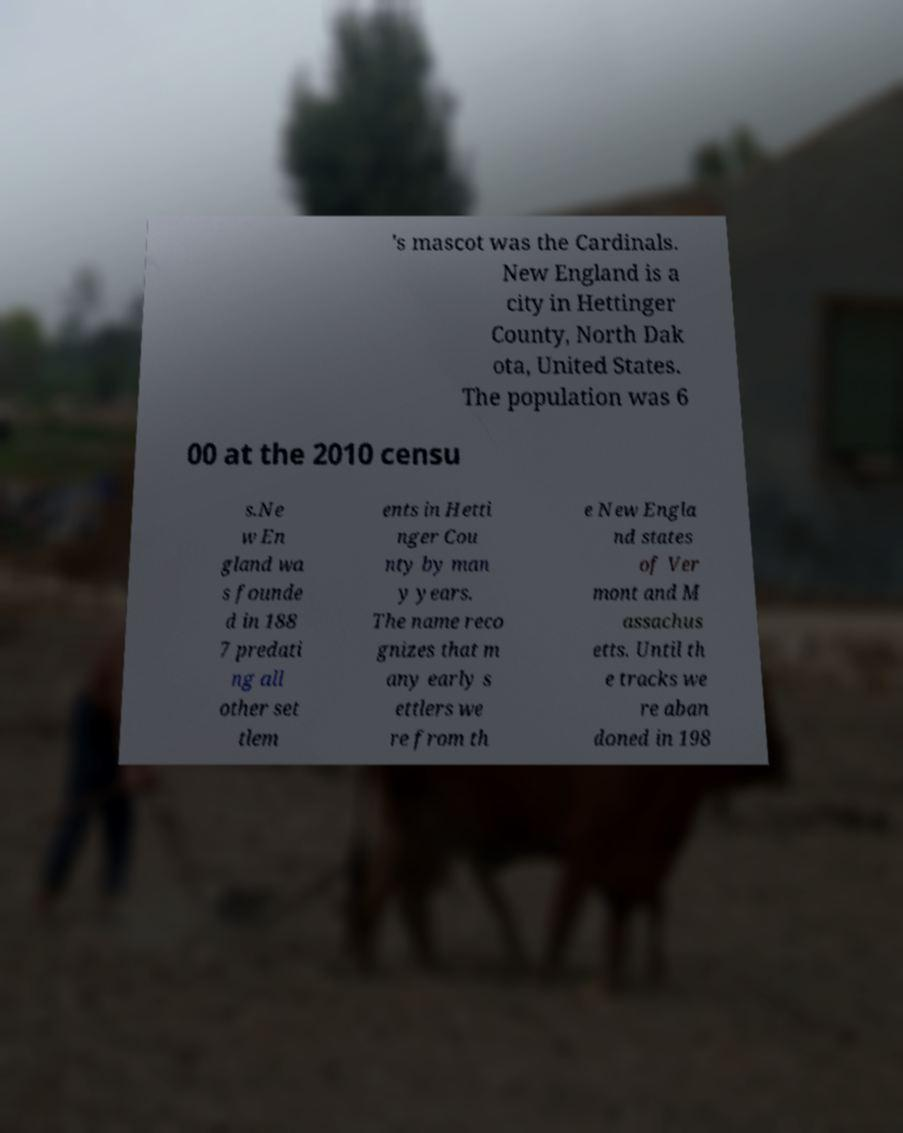There's text embedded in this image that I need extracted. Can you transcribe it verbatim? 's mascot was the Cardinals. New England is a city in Hettinger County, North Dak ota, United States. The population was 6 00 at the 2010 censu s.Ne w En gland wa s founde d in 188 7 predati ng all other set tlem ents in Hetti nger Cou nty by man y years. The name reco gnizes that m any early s ettlers we re from th e New Engla nd states of Ver mont and M assachus etts. Until th e tracks we re aban doned in 198 